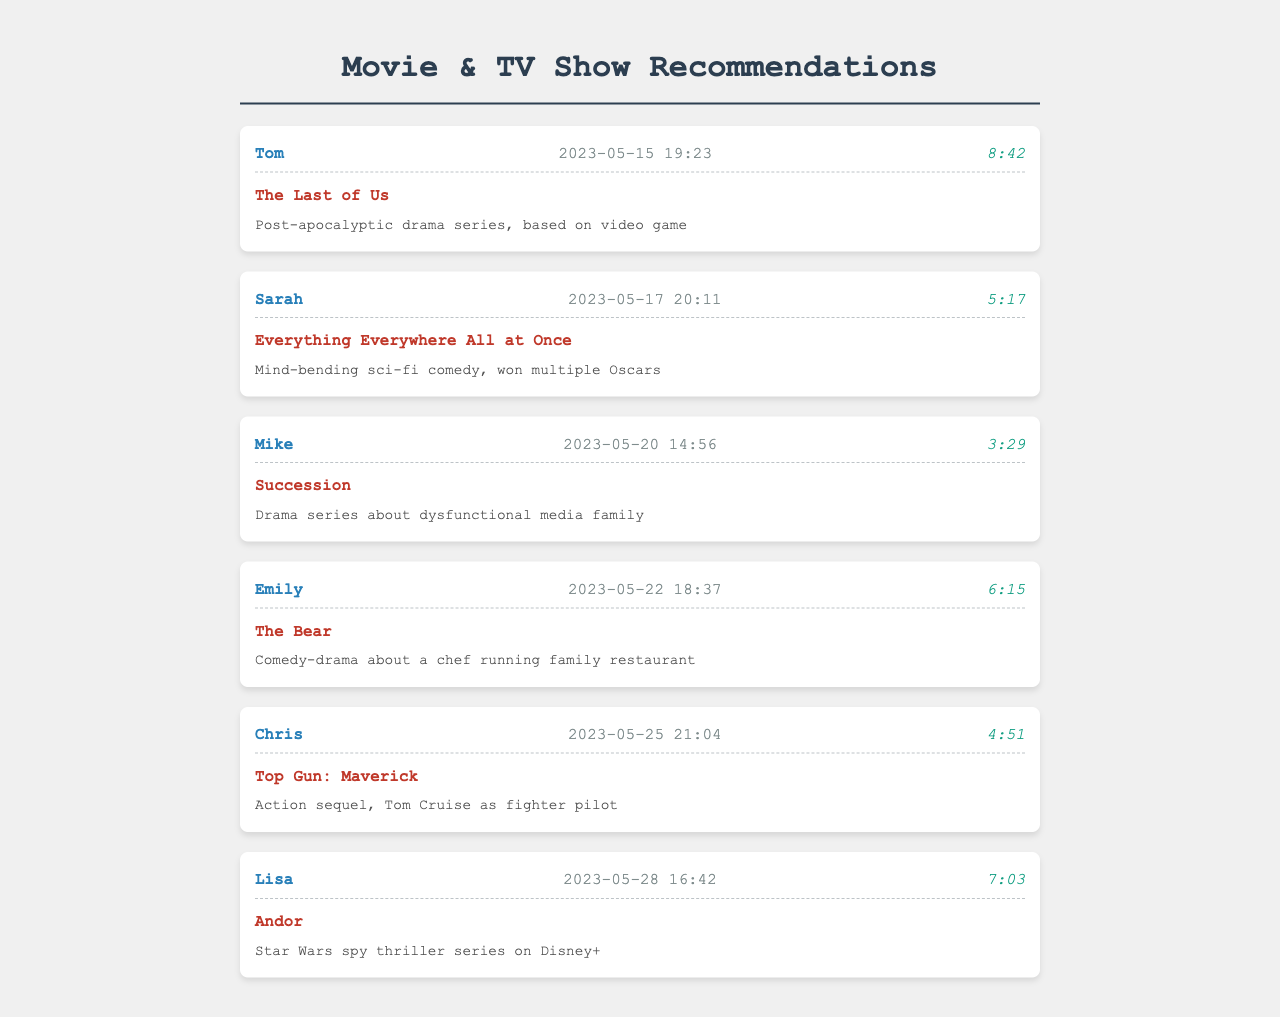What is the name of the first caller? The first caller in the document is Tom, as shown in the call logs.
Answer: Tom What was the duration of the call from Sarah? The call from Sarah lasted for 5 minutes and 17 seconds, as indicated in the call log.
Answer: 5:17 What movie was recommended by Emily? Emily recommended "The Bear," which is listed in her call log entry.
Answer: The Bear How many calls were made in total? There are a total of six calls documented, as seen in the provided call logs.
Answer: 6 Which show has the longest call duration? The longest call duration is attributed to Tom with 8 minutes and 42 seconds.
Answer: 8:42 What genre is "Everything Everywhere All at Once"? The genre of "Everything Everywhere All at Once" is a mind-bending sci-fi comedy, noted in the recommendation details.
Answer: Sci-fi comedy Who recommended the action sequel featuring Tom Cruise? Chris recommended the action sequel "Top Gun: Maverick," as noted in his call entry.
Answer: Chris On what date did Mike make his call? Mike made his call on May 20, 2023, as mentioned in the date-time field of the call log.
Answer: 2023-05-20 